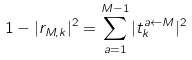<formula> <loc_0><loc_0><loc_500><loc_500>1 - | r _ { M , k } | ^ { 2 } = \sum _ { a = 1 } ^ { M - 1 } | t ^ { a \leftarrow M } _ { k } | ^ { 2 }</formula> 